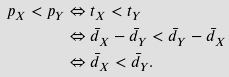Convert formula to latex. <formula><loc_0><loc_0><loc_500><loc_500>p _ { X } < p _ { Y } & \Leftrightarrow t _ { X } < t _ { Y } \\ & \Leftrightarrow \bar { d } _ { X } - \bar { d } _ { Y } < \bar { d } _ { Y } - \bar { d } _ { X } \\ & \Leftrightarrow \bar { d } _ { X } < \bar { d } _ { Y } .</formula> 